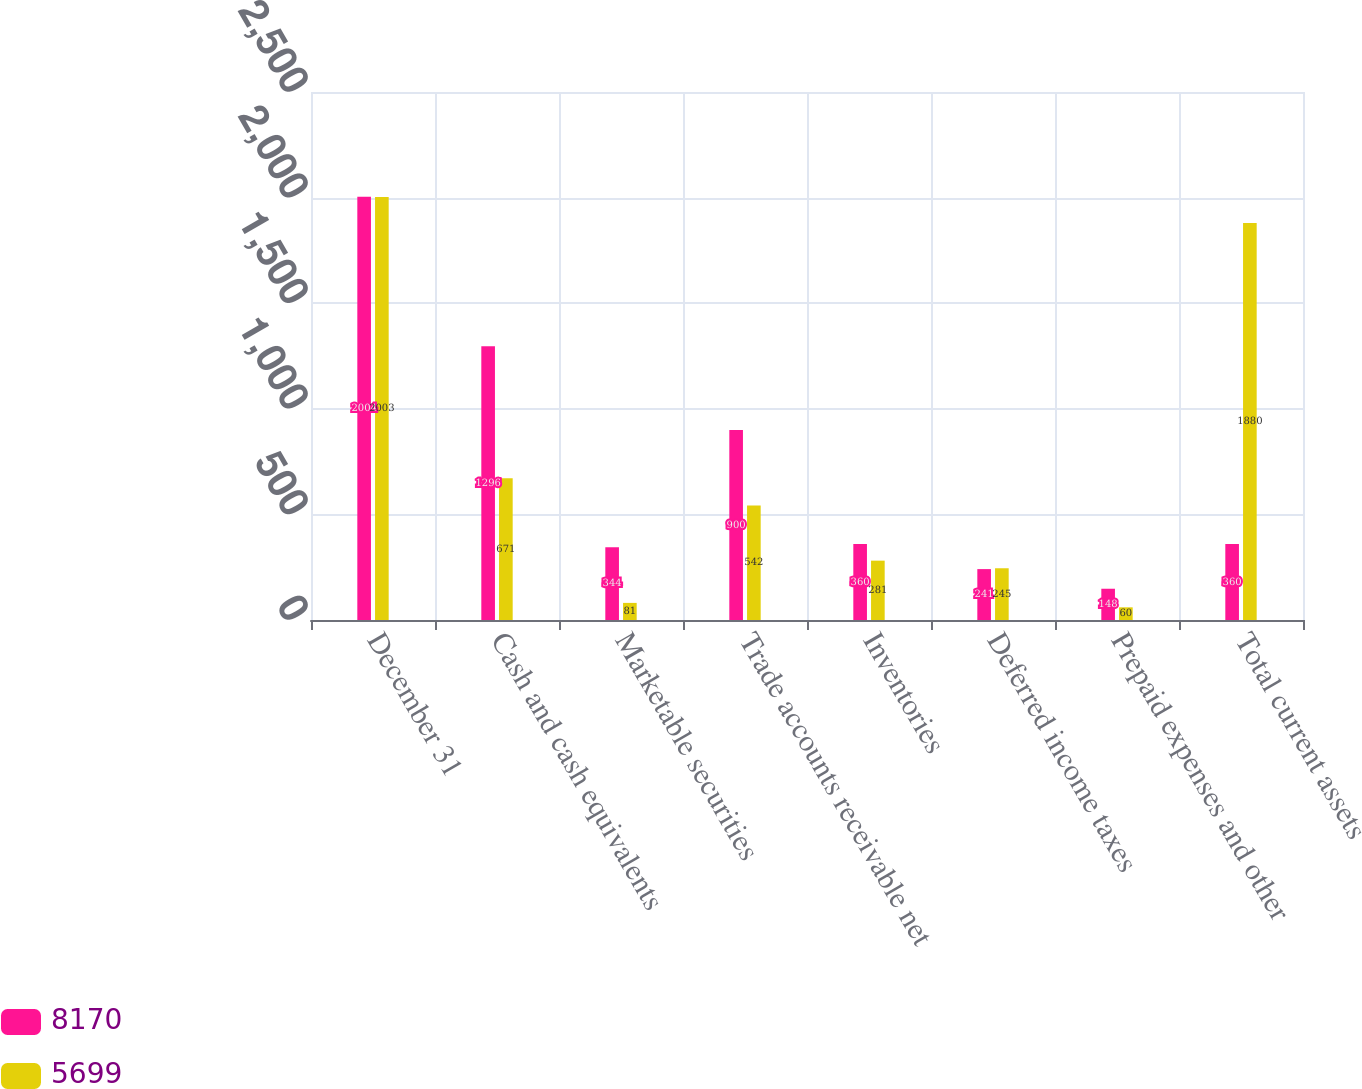<chart> <loc_0><loc_0><loc_500><loc_500><stacked_bar_chart><ecel><fcel>December 31<fcel>Cash and cash equivalents<fcel>Marketable securities<fcel>Trade accounts receivable net<fcel>Inventories<fcel>Deferred income taxes<fcel>Prepaid expenses and other<fcel>Total current assets<nl><fcel>8170<fcel>2004<fcel>1296<fcel>344<fcel>900<fcel>360<fcel>241<fcel>148<fcel>360<nl><fcel>5699<fcel>2003<fcel>671<fcel>81<fcel>542<fcel>281<fcel>245<fcel>60<fcel>1880<nl></chart> 